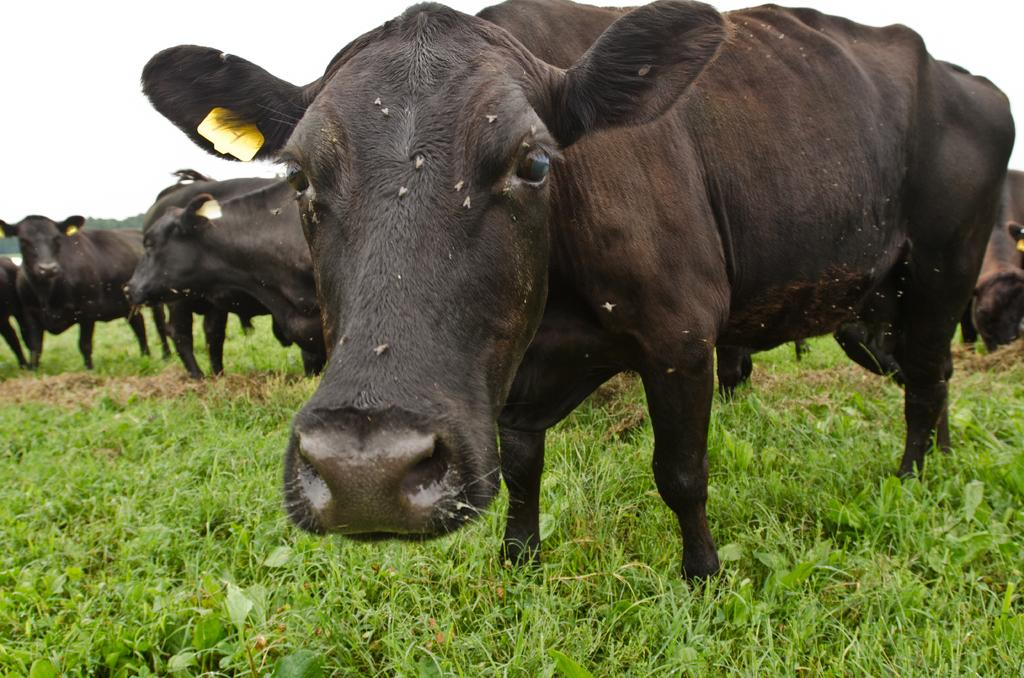What animals are present in the image? There is a group of buffaloes in the image. What type of terrain are the buffaloes on? The buffaloes are on grassy land. Where are the buffaloes located in the image? The buffaloes are in the middle of the image. What can be seen above the buffaloes in the image? There is a sky visible in the image. What type of market can be seen in the image? There is no market present in the image; it features a group of buffaloes on grassy land. How many railway tracks are visible in the image? There are no railway tracks present in the image. 